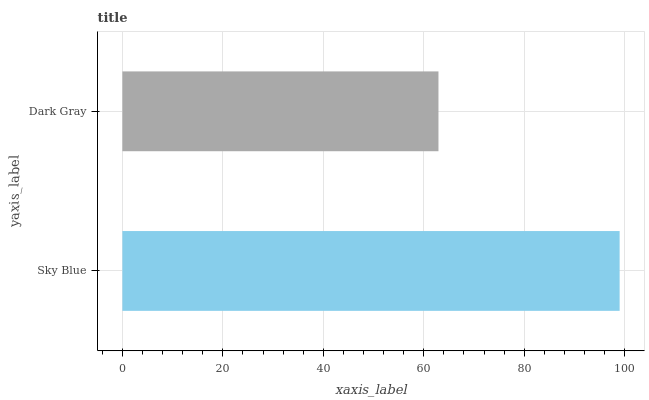Is Dark Gray the minimum?
Answer yes or no. Yes. Is Sky Blue the maximum?
Answer yes or no. Yes. Is Dark Gray the maximum?
Answer yes or no. No. Is Sky Blue greater than Dark Gray?
Answer yes or no. Yes. Is Dark Gray less than Sky Blue?
Answer yes or no. Yes. Is Dark Gray greater than Sky Blue?
Answer yes or no. No. Is Sky Blue less than Dark Gray?
Answer yes or no. No. Is Sky Blue the high median?
Answer yes or no. Yes. Is Dark Gray the low median?
Answer yes or no. Yes. Is Dark Gray the high median?
Answer yes or no. No. Is Sky Blue the low median?
Answer yes or no. No. 